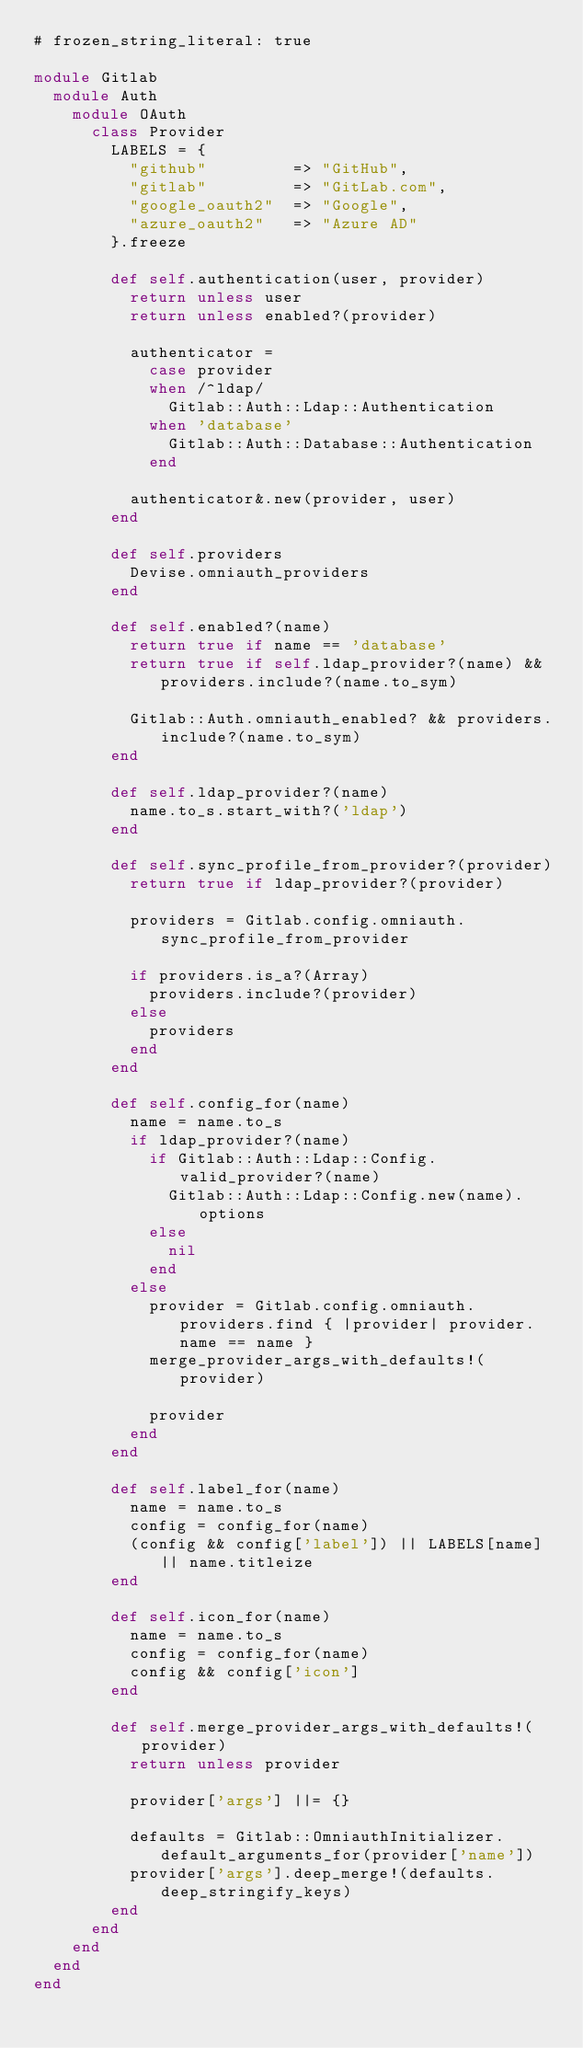<code> <loc_0><loc_0><loc_500><loc_500><_Ruby_># frozen_string_literal: true

module Gitlab
  module Auth
    module OAuth
      class Provider
        LABELS = {
          "github"         => "GitHub",
          "gitlab"         => "GitLab.com",
          "google_oauth2"  => "Google",
          "azure_oauth2"   => "Azure AD"
        }.freeze

        def self.authentication(user, provider)
          return unless user
          return unless enabled?(provider)

          authenticator =
            case provider
            when /^ldap/
              Gitlab::Auth::Ldap::Authentication
            when 'database'
              Gitlab::Auth::Database::Authentication
            end

          authenticator&.new(provider, user)
        end

        def self.providers
          Devise.omniauth_providers
        end

        def self.enabled?(name)
          return true if name == 'database'
          return true if self.ldap_provider?(name) && providers.include?(name.to_sym)

          Gitlab::Auth.omniauth_enabled? && providers.include?(name.to_sym)
        end

        def self.ldap_provider?(name)
          name.to_s.start_with?('ldap')
        end

        def self.sync_profile_from_provider?(provider)
          return true if ldap_provider?(provider)

          providers = Gitlab.config.omniauth.sync_profile_from_provider

          if providers.is_a?(Array)
            providers.include?(provider)
          else
            providers
          end
        end

        def self.config_for(name)
          name = name.to_s
          if ldap_provider?(name)
            if Gitlab::Auth::Ldap::Config.valid_provider?(name)
              Gitlab::Auth::Ldap::Config.new(name).options
            else
              nil
            end
          else
            provider = Gitlab.config.omniauth.providers.find { |provider| provider.name == name }
            merge_provider_args_with_defaults!(provider)

            provider
          end
        end

        def self.label_for(name)
          name = name.to_s
          config = config_for(name)
          (config && config['label']) || LABELS[name] || name.titleize
        end

        def self.icon_for(name)
          name = name.to_s
          config = config_for(name)
          config && config['icon']
        end

        def self.merge_provider_args_with_defaults!(provider)
          return unless provider

          provider['args'] ||= {}

          defaults = Gitlab::OmniauthInitializer.default_arguments_for(provider['name'])
          provider['args'].deep_merge!(defaults.deep_stringify_keys)
        end
      end
    end
  end
end
</code> 